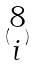Convert formula to latex. <formula><loc_0><loc_0><loc_500><loc_500>( \begin{matrix} 8 \\ i \end{matrix} )</formula> 